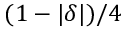<formula> <loc_0><loc_0><loc_500><loc_500>( 1 - | \delta | ) / 4</formula> 